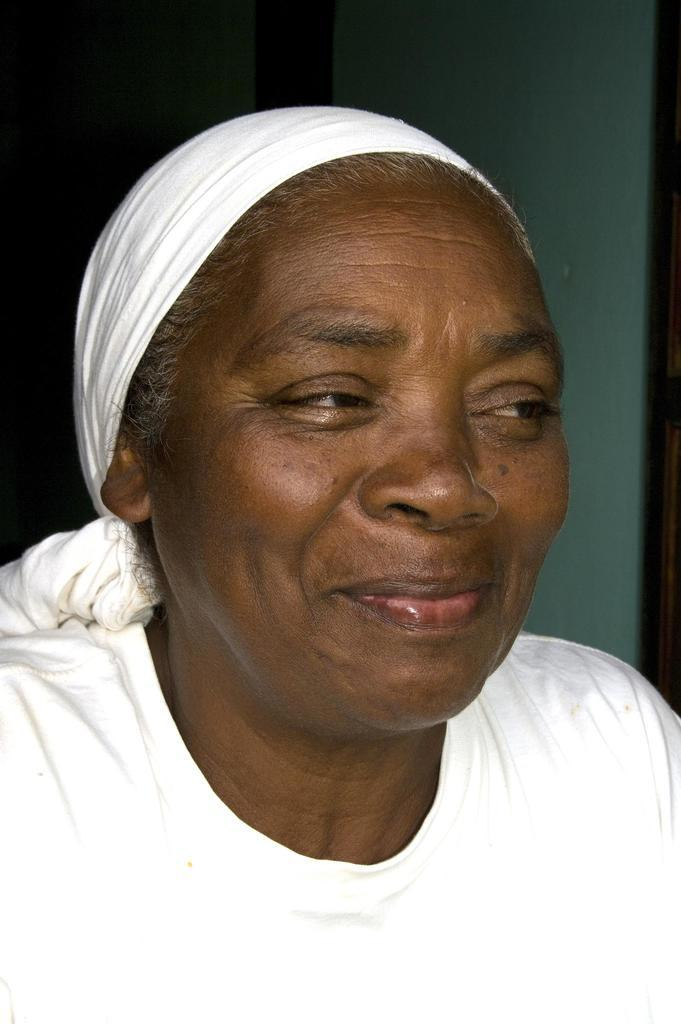What is present in the image? There is a person in the image. How is the person's expression in the image? The person is smiling. What type of oatmeal is the fireman eating for dinner in the image? There is no fireman or oatmeal present in the image. The image only features a person who is smiling. 